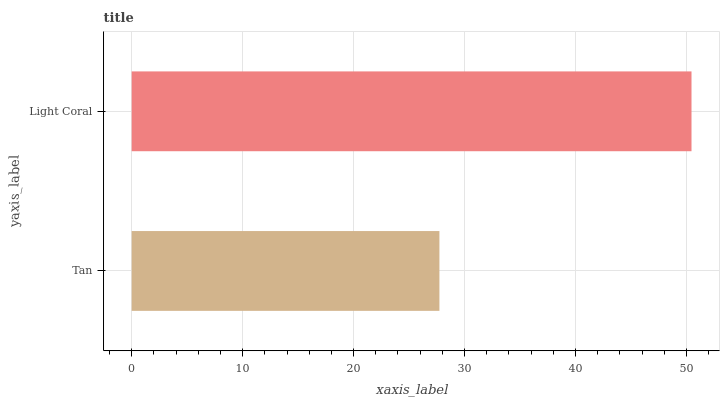Is Tan the minimum?
Answer yes or no. Yes. Is Light Coral the maximum?
Answer yes or no. Yes. Is Light Coral the minimum?
Answer yes or no. No. Is Light Coral greater than Tan?
Answer yes or no. Yes. Is Tan less than Light Coral?
Answer yes or no. Yes. Is Tan greater than Light Coral?
Answer yes or no. No. Is Light Coral less than Tan?
Answer yes or no. No. Is Light Coral the high median?
Answer yes or no. Yes. Is Tan the low median?
Answer yes or no. Yes. Is Tan the high median?
Answer yes or no. No. Is Light Coral the low median?
Answer yes or no. No. 